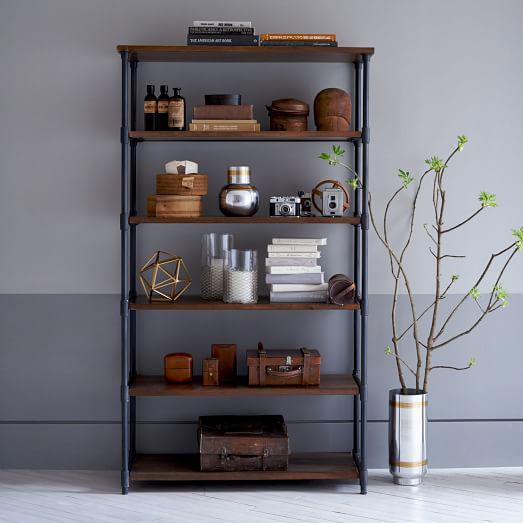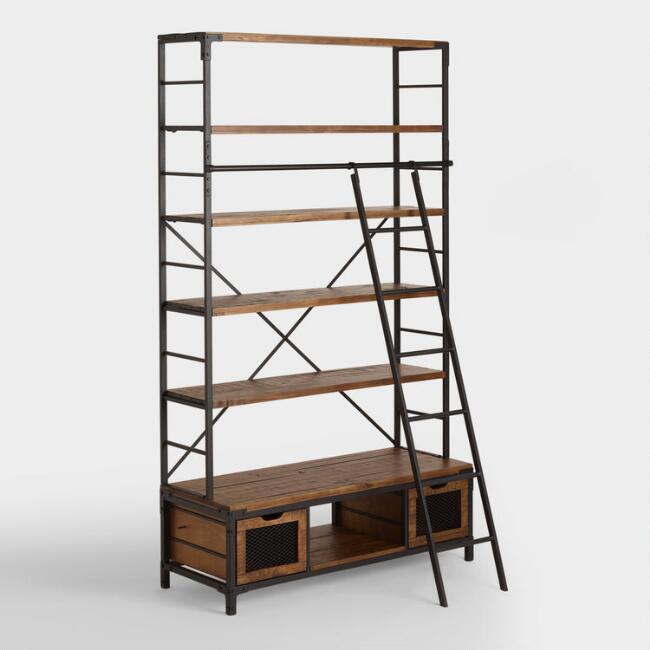The first image is the image on the left, the second image is the image on the right. Evaluate the accuracy of this statement regarding the images: "One of the images shows a bookshelf that is empty.". Is it true? Answer yes or no. Yes. The first image is the image on the left, the second image is the image on the right. Considering the images on both sides, is "An image shows a completely empty set of shelves." valid? Answer yes or no. Yes. 